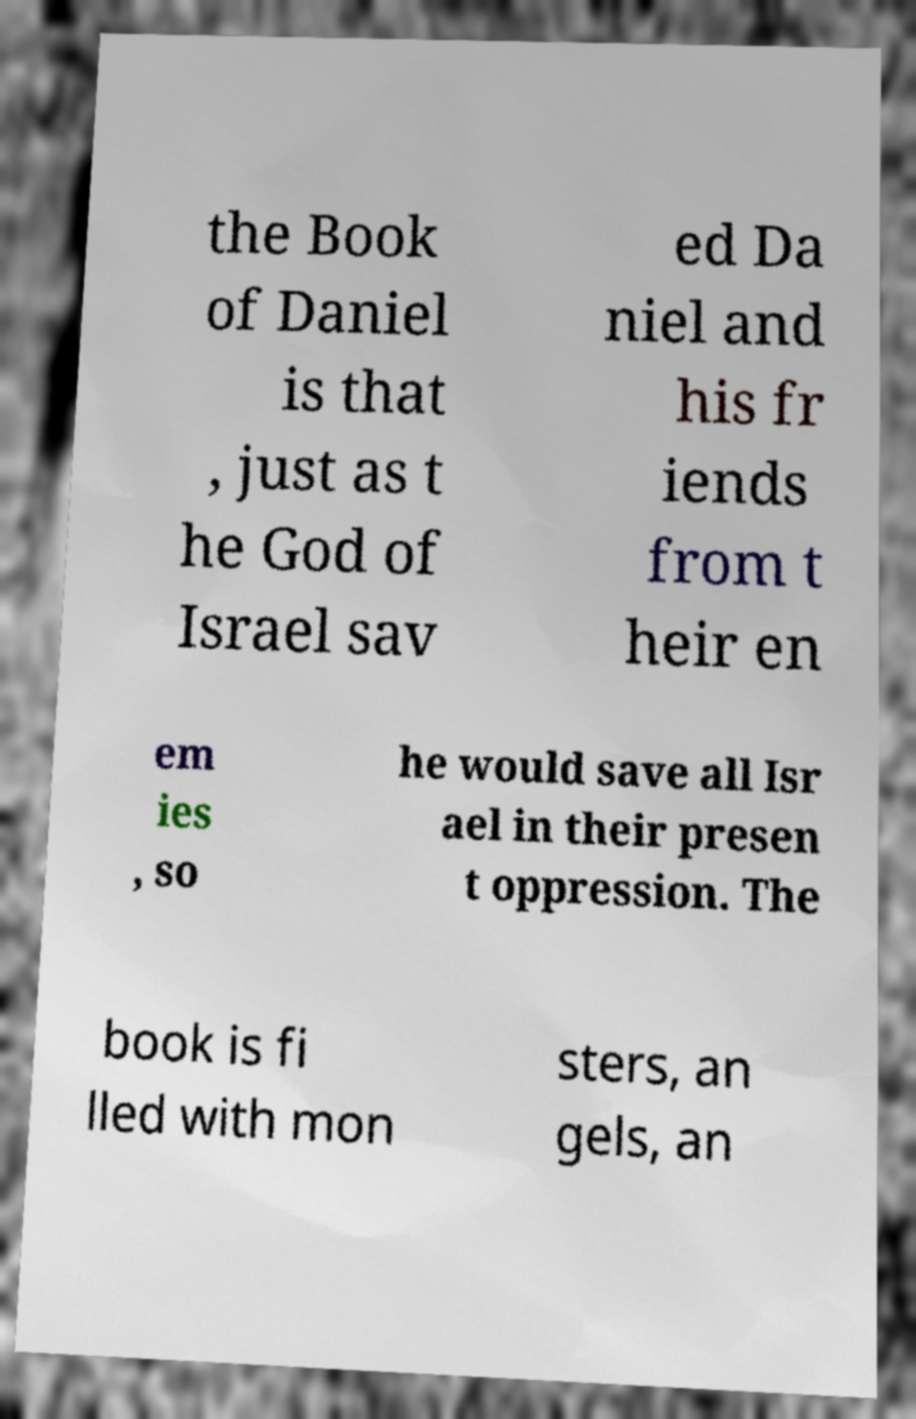There's text embedded in this image that I need extracted. Can you transcribe it verbatim? the Book of Daniel is that , just as t he God of Israel sav ed Da niel and his fr iends from t heir en em ies , so he would save all Isr ael in their presen t oppression. The book is fi lled with mon sters, an gels, an 